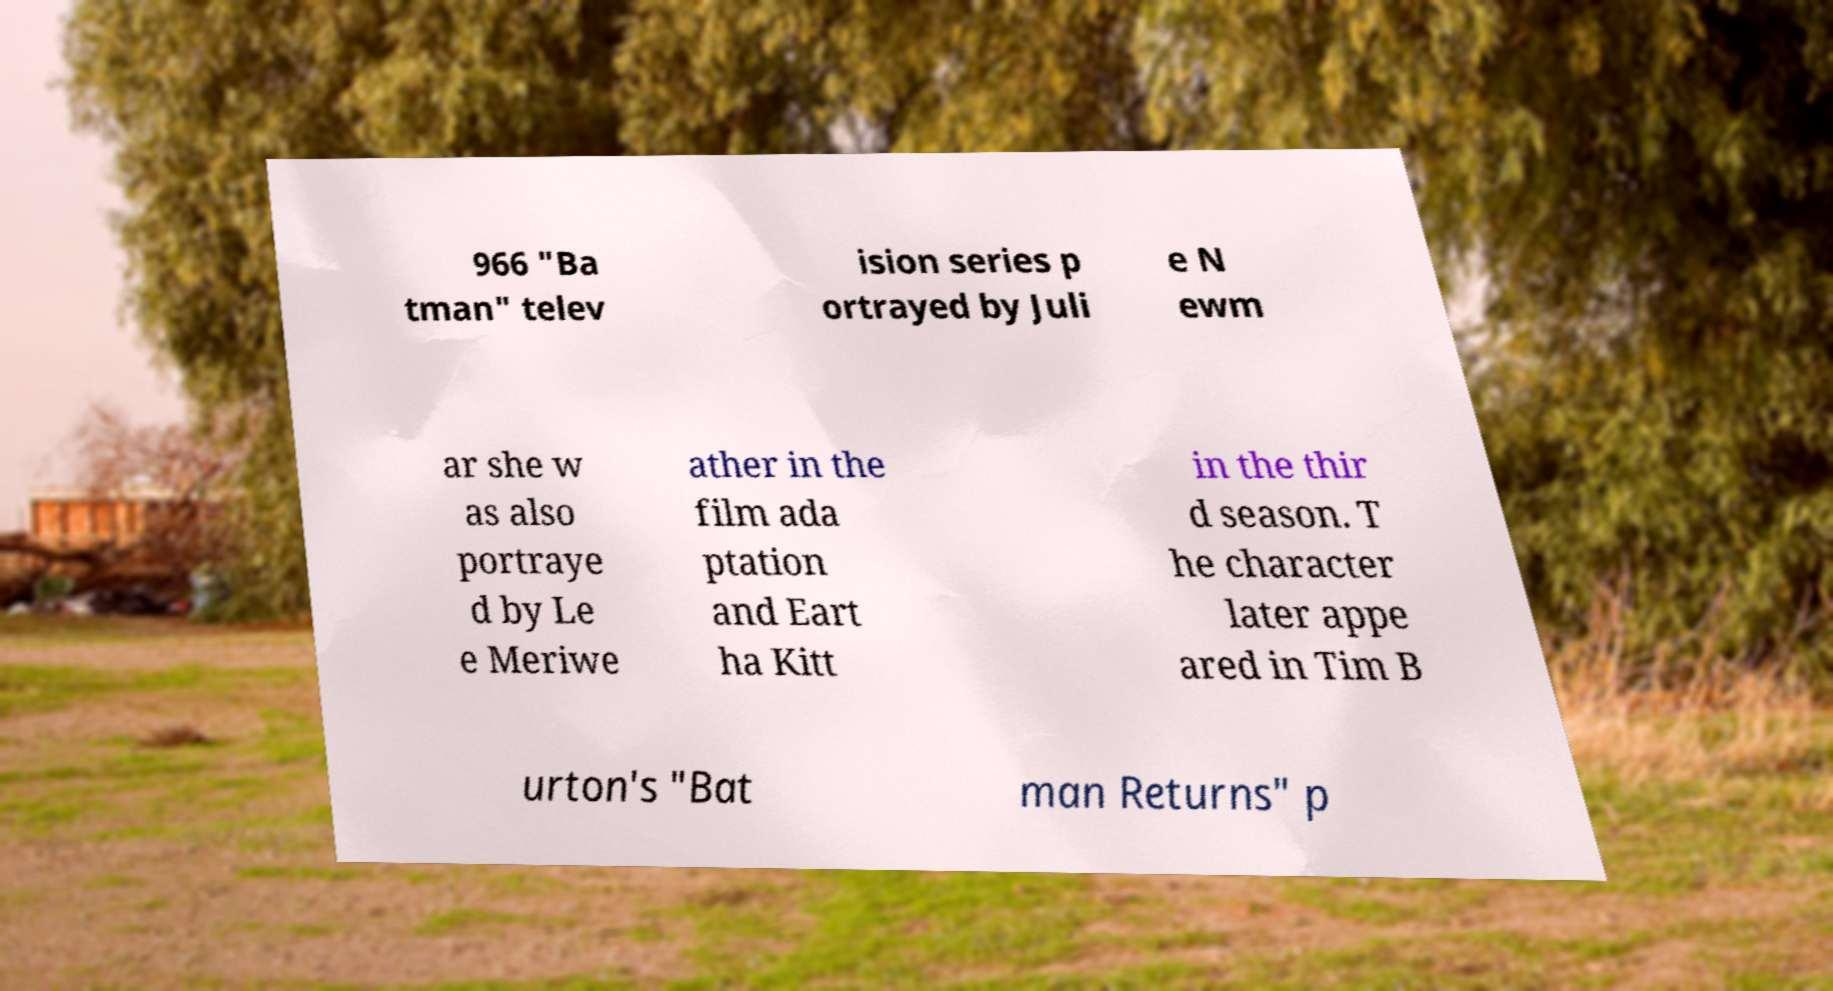I need the written content from this picture converted into text. Can you do that? 966 "Ba tman" telev ision series p ortrayed by Juli e N ewm ar she w as also portraye d by Le e Meriwe ather in the film ada ptation and Eart ha Kitt in the thir d season. T he character later appe ared in Tim B urton's "Bat man Returns" p 